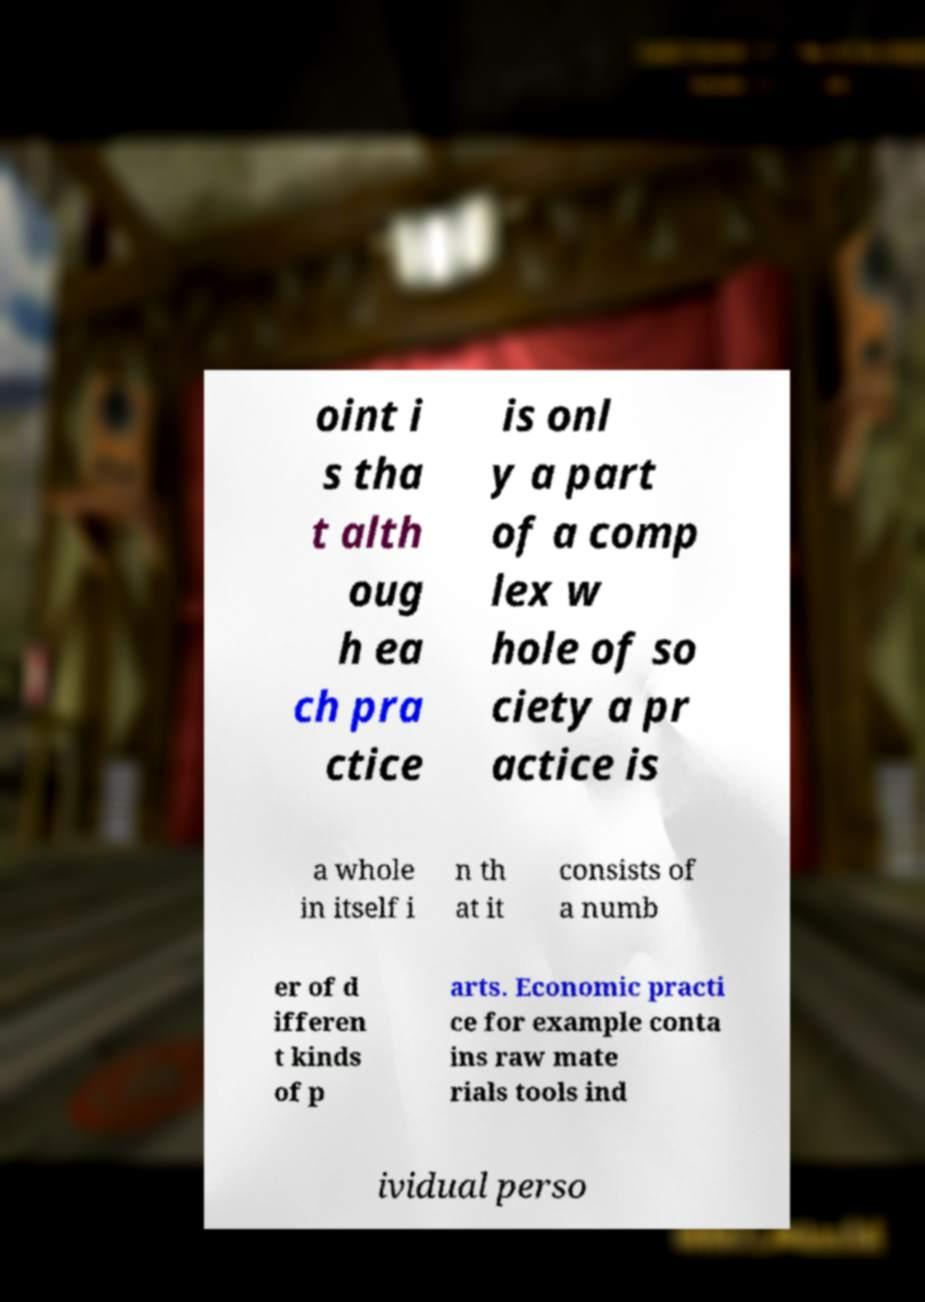Can you accurately transcribe the text from the provided image for me? oint i s tha t alth oug h ea ch pra ctice is onl y a part of a comp lex w hole of so ciety a pr actice is a whole in itself i n th at it consists of a numb er of d ifferen t kinds of p arts. Economic practi ce for example conta ins raw mate rials tools ind ividual perso 